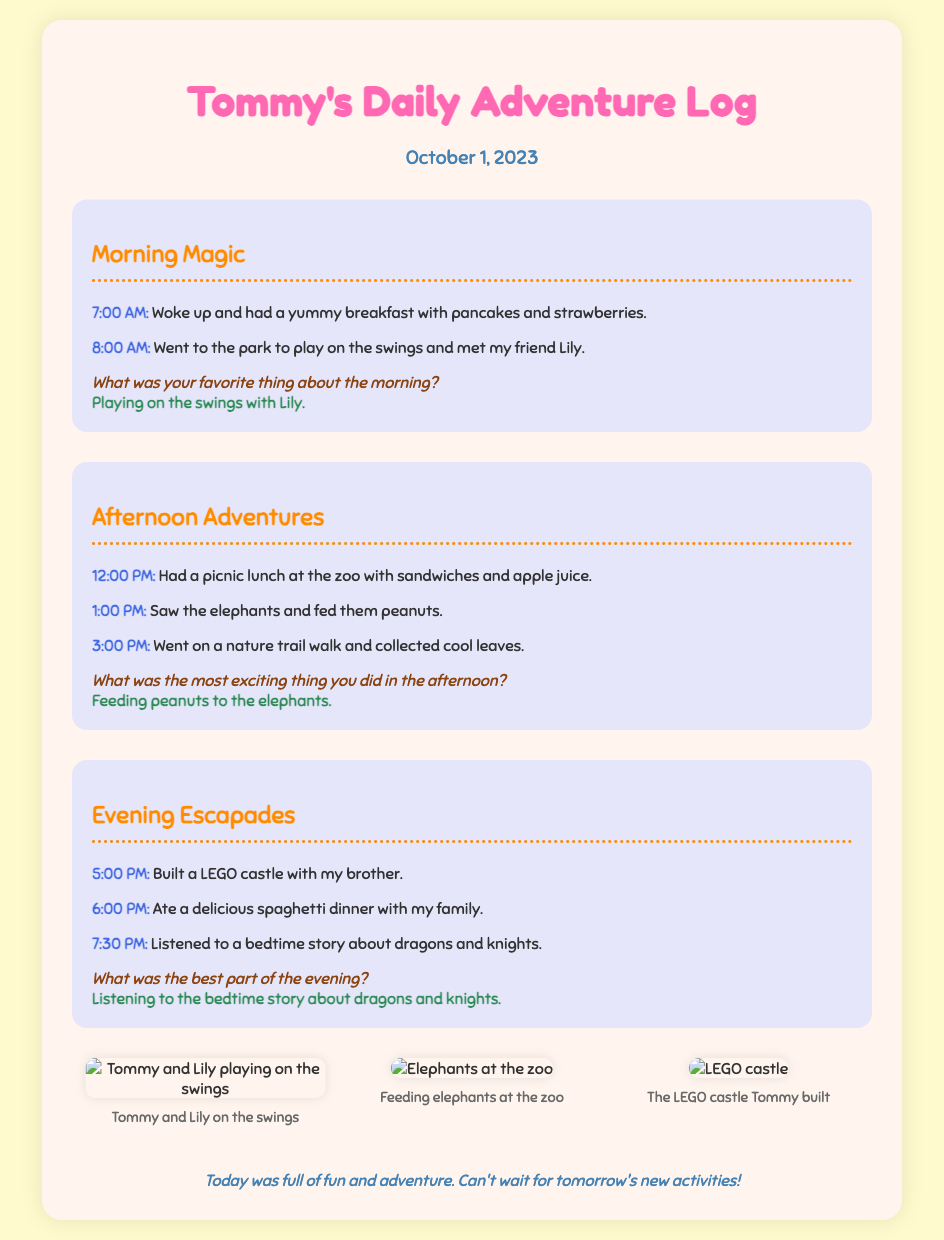What time did Tommy wake up? The document states that Tommy woke up at 7:00 AM.
Answer: 7:00 AM Who did Tommy meet at the park? According to the document, Tommy met his friend Lily at the park.
Answer: Lily What was for lunch at the zoo? The document mentions that Tommy had sandwiches and apple juice for lunch at the zoo.
Answer: Sandwiches and apple juice What activity did Tommy do at 1:00 PM? At 1:00 PM, Tommy saw the elephants and fed them peanuts, as per the document.
Answer: Saw the elephants and fed them peanuts What did Tommy build in the evening? The document states that Tommy built a LEGO castle with his brother in the evening.
Answer: LEGO castle What was the best part of the evening? The best part of the evening was listening to a bedtime story about dragons and knights.
Answer: Listening to the bedtime story about dragons and knights How many different activities did Tommy do in the afternoon? The document lists three activities that Tommy did in the afternoon: having a picnic, seeing the elephants, and going on a nature trail walk.
Answer: Three What genre was the bedtime story Tommy listened to? The bedtime story was about dragons and knights, as mentioned in the document.
Answer: Dragons and knights What type of illustrations are included in the document? The document includes illustrations related to morning swings, elephants at the zoo, and a LEGO castle.
Answer: Morning swings, elephants at the zoo, LEGO castle 